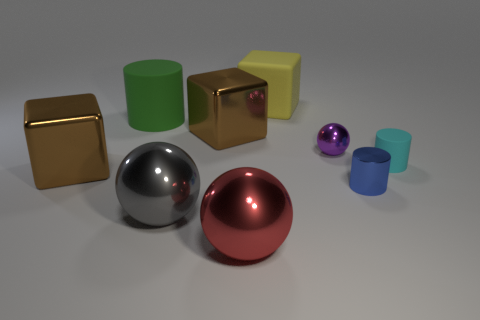Subtract all blue cylinders. How many cylinders are left? 2 Subtract all balls. How many objects are left? 6 Add 1 blue metal things. How many objects exist? 10 Subtract 2 spheres. How many spheres are left? 1 Subtract all cyan cylinders. How many cylinders are left? 2 Subtract all gray cubes. Subtract all purple balls. How many cubes are left? 3 Subtract all yellow balls. How many cyan cubes are left? 0 Subtract all purple rubber blocks. Subtract all large cylinders. How many objects are left? 8 Add 7 brown objects. How many brown objects are left? 9 Add 6 small blue metallic balls. How many small blue metallic balls exist? 6 